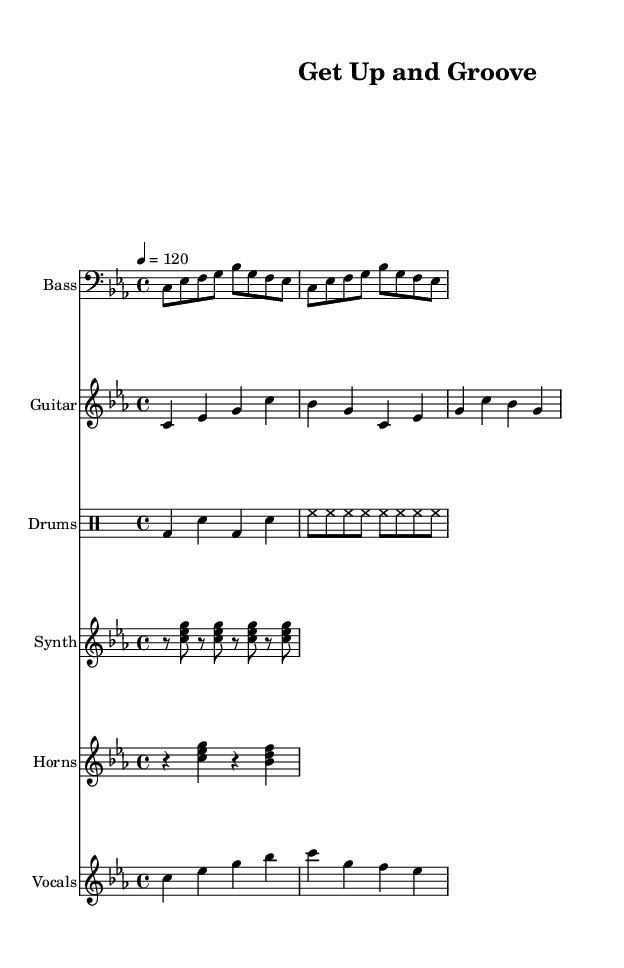What is the key signature of this music? The music is in C minor, which is indicated by the key signature with three flats (B♭, E♭, A♭).
Answer: C minor What is the time signature of this piece? The time signature is shown as 4/4, which means there are four beats in each measure and the quarter note gets one beat.
Answer: 4/4 What is the tempo marking for this piece? The tempo is marked as 4 equals 120, indicating that there are 120 beats per minute, which means the music should be played at a brisk pace.
Answer: 120 How many beats are in each measure based on the time signature? Since the time signature is 4/4, each measure contains four beats. This is derived directly from the 4 in the numerator of the time signature.
Answer: 4 What is the primary instrument featured in the chorus melody? The chorus melody is written in the treble clef, indicating it is primarily for the voice which can be performed by singers.
Answer: Vocals Which genres influence the overall style of this piece? The predominant elements of this piece, including the bass lines and drum patterns, suggest influence from Funk music, characterized by strong rhythmic grooves and melodic hooks.
Answer: Funk 